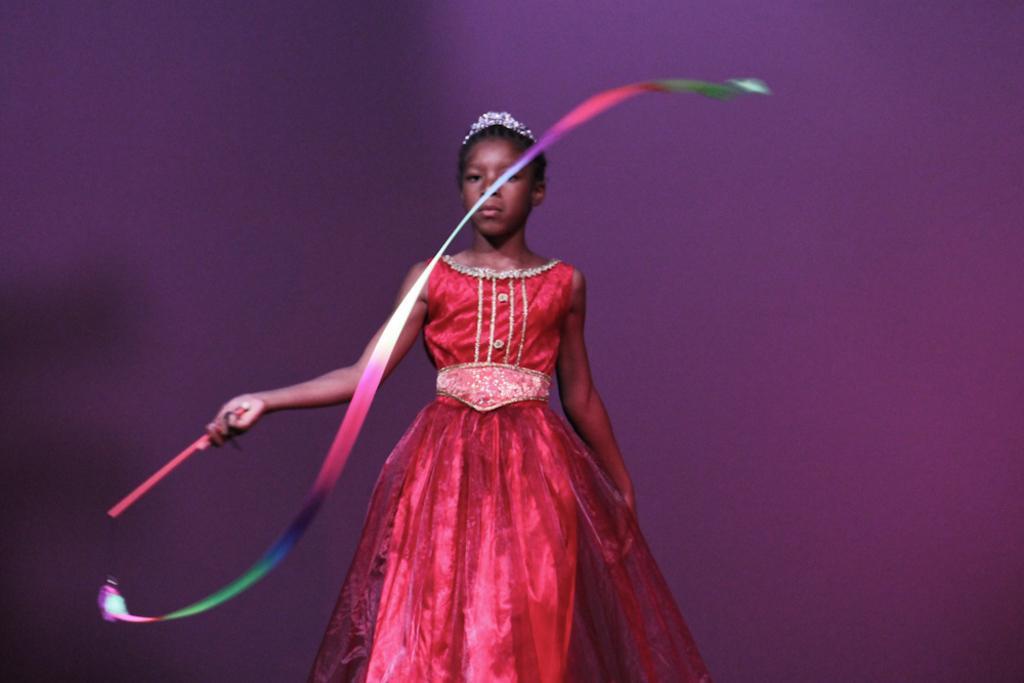Could you give a brief overview of what you see in this image? In this picture there is a girl in the center of the image, by holding a colorful ribbon in her hand. 